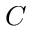Convert formula to latex. <formula><loc_0><loc_0><loc_500><loc_500>C</formula> 